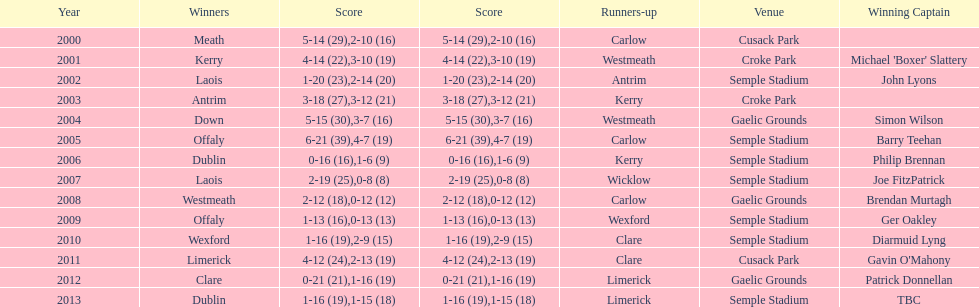Who was the captain that claimed the first victory? Michael 'Boxer' Slattery. Give me the full table as a dictionary. {'header': ['Year', 'Winners', 'Score', 'Score', 'Runners-up', 'Venue', 'Winning Captain'], 'rows': [['2000', 'Meath', '5-14 (29)', '2-10 (16)', 'Carlow', 'Cusack Park', ''], ['2001', 'Kerry', '4-14 (22)', '3-10 (19)', 'Westmeath', 'Croke Park', "Michael 'Boxer' Slattery"], ['2002', 'Laois', '1-20 (23)', '2-14 (20)', 'Antrim', 'Semple Stadium', 'John Lyons'], ['2003', 'Antrim', '3-18 (27)', '3-12 (21)', 'Kerry', 'Croke Park', ''], ['2004', 'Down', '5-15 (30)', '3-7 (16)', 'Westmeath', 'Gaelic Grounds', 'Simon Wilson'], ['2005', 'Offaly', '6-21 (39)', '4-7 (19)', 'Carlow', 'Semple Stadium', 'Barry Teehan'], ['2006', 'Dublin', '0-16 (16)', '1-6 (9)', 'Kerry', 'Semple Stadium', 'Philip Brennan'], ['2007', 'Laois', '2-19 (25)', '0-8 (8)', 'Wicklow', 'Semple Stadium', 'Joe FitzPatrick'], ['2008', 'Westmeath', '2-12 (18)', '0-12 (12)', 'Carlow', 'Gaelic Grounds', 'Brendan Murtagh'], ['2009', 'Offaly', '1-13 (16)', '0-13 (13)', 'Wexford', 'Semple Stadium', 'Ger Oakley'], ['2010', 'Wexford', '1-16 (19)', '2-9 (15)', 'Clare', 'Semple Stadium', 'Diarmuid Lyng'], ['2011', 'Limerick', '4-12 (24)', '2-13 (19)', 'Clare', 'Cusack Park', "Gavin O'Mahony"], ['2012', 'Clare', '0-21 (21)', '1-16 (19)', 'Limerick', 'Gaelic Grounds', 'Patrick Donnellan'], ['2013', 'Dublin', '1-16 (19)', '1-15 (18)', 'Limerick', 'Semple Stadium', 'TBC']]} 